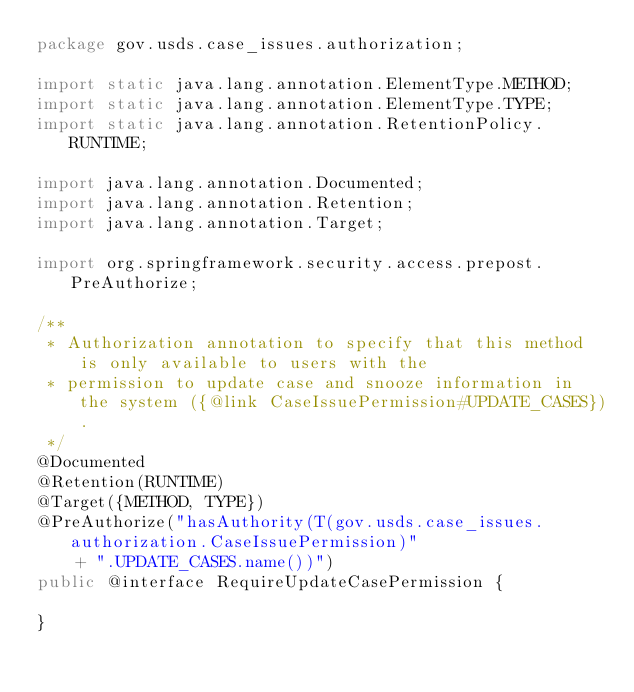<code> <loc_0><loc_0><loc_500><loc_500><_Java_>package gov.usds.case_issues.authorization;

import static java.lang.annotation.ElementType.METHOD;
import static java.lang.annotation.ElementType.TYPE;
import static java.lang.annotation.RetentionPolicy.RUNTIME;

import java.lang.annotation.Documented;
import java.lang.annotation.Retention;
import java.lang.annotation.Target;

import org.springframework.security.access.prepost.PreAuthorize;

/**
 * Authorization annotation to specify that this method is only available to users with the
 * permission to update case and snooze information in the system ({@link CaseIssuePermission#UPDATE_CASES}).
 */
@Documented
@Retention(RUNTIME)
@Target({METHOD, TYPE})
@PreAuthorize("hasAuthority(T(gov.usds.case_issues.authorization.CaseIssuePermission)"
		+ ".UPDATE_CASES.name())")
public @interface RequireUpdateCasePermission {

}
</code> 